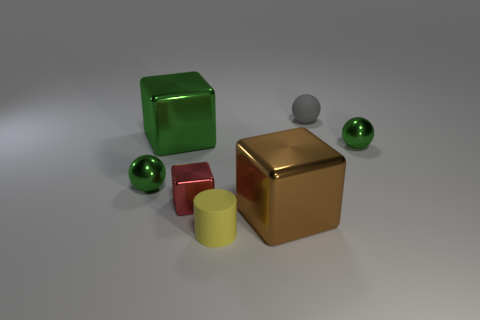Is the red metallic thing the same size as the brown metallic cube?
Your answer should be compact. No. What number of tiny objects are in front of the tiny red metallic block to the right of the green ball to the left of the tiny shiny block?
Provide a succinct answer. 1. There is a tiny green shiny object that is on the left side of the large green cube; how many large green objects are left of it?
Make the answer very short. 0. There is a large green metal object; how many metallic balls are to the right of it?
Offer a terse response. 1. What number of other objects are the same size as the gray rubber ball?
Keep it short and to the point. 4. There is a green metal object that is the same shape as the brown object; what size is it?
Offer a very short reply. Large. There is a green thing on the right side of the yellow matte thing; what is its shape?
Your response must be concise. Sphere. The matte thing that is behind the sphere left of the tiny red cube is what color?
Provide a succinct answer. Gray. How many objects are either green things to the left of the yellow cylinder or matte cylinders?
Provide a succinct answer. 3. Does the brown object have the same size as the green block left of the tiny matte cylinder?
Provide a short and direct response. Yes. 